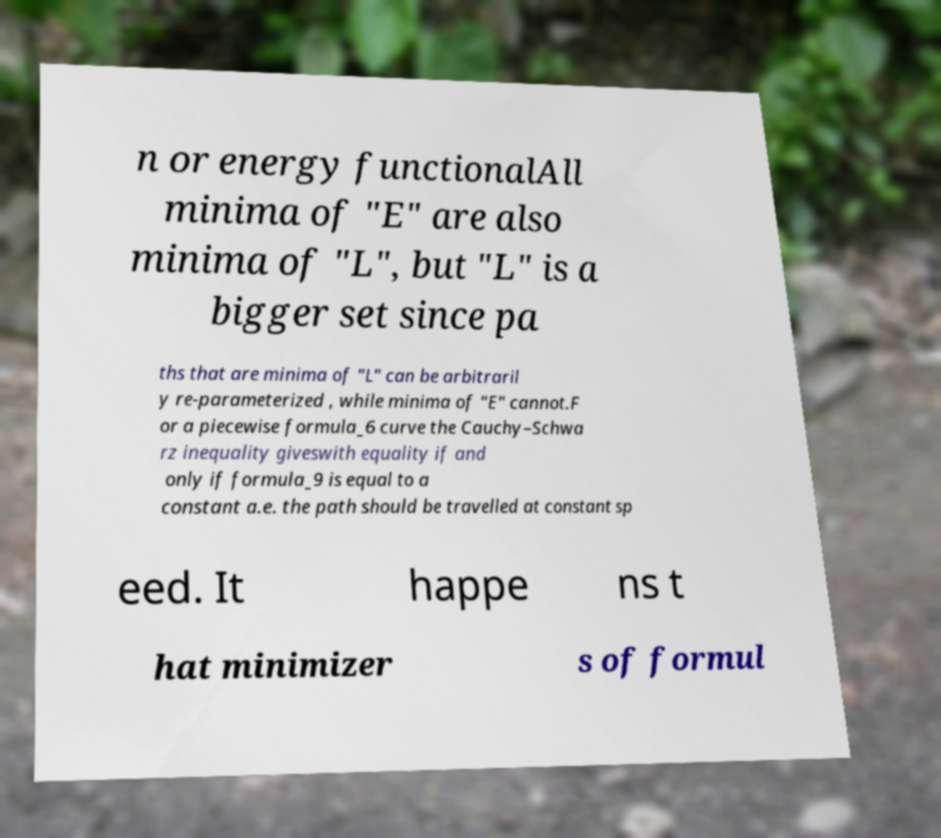There's text embedded in this image that I need extracted. Can you transcribe it verbatim? n or energy functionalAll minima of "E" are also minima of "L", but "L" is a bigger set since pa ths that are minima of "L" can be arbitraril y re-parameterized , while minima of "E" cannot.F or a piecewise formula_6 curve the Cauchy–Schwa rz inequality giveswith equality if and only if formula_9 is equal to a constant a.e. the path should be travelled at constant sp eed. It happe ns t hat minimizer s of formul 